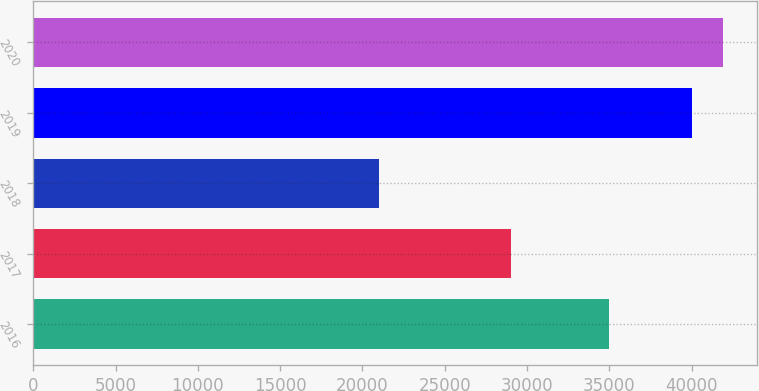<chart> <loc_0><loc_0><loc_500><loc_500><bar_chart><fcel>2016<fcel>2017<fcel>2018<fcel>2019<fcel>2020<nl><fcel>35000<fcel>29000<fcel>21000<fcel>40000<fcel>41900<nl></chart> 